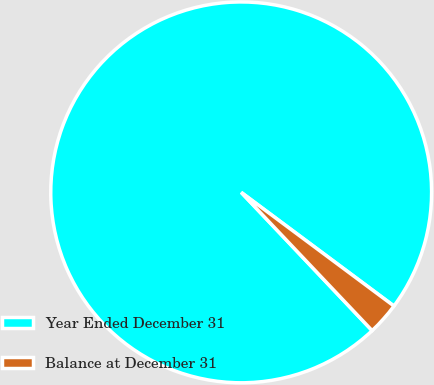Convert chart. <chart><loc_0><loc_0><loc_500><loc_500><pie_chart><fcel>Year Ended December 31<fcel>Balance at December 31<nl><fcel>97.25%<fcel>2.75%<nl></chart> 